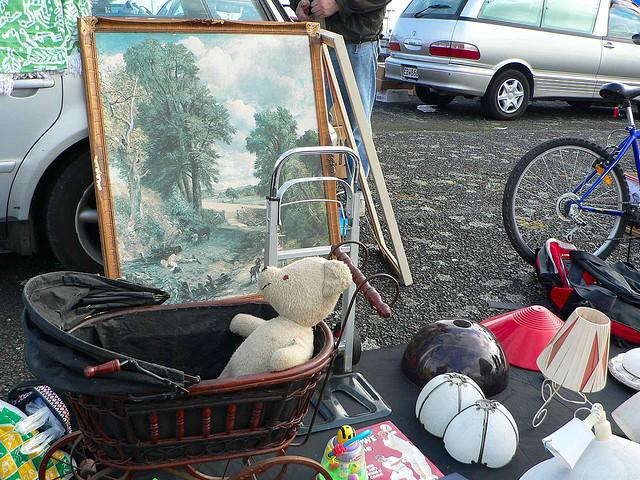This umbrellas used in which lamp? far right 